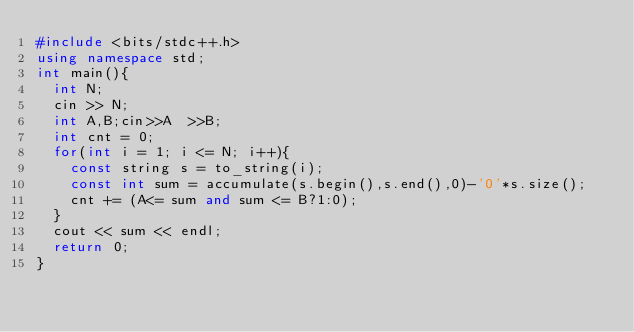<code> <loc_0><loc_0><loc_500><loc_500><_C++_>#include <bits/stdc++.h>
using namespace std;
int main(){
  int N;
  cin >> N;
  int A,B;cin>>A  >>B;
  int cnt = 0;
  for(int i = 1; i <= N; i++){
  	const string s = to_string(i);
    const int sum = accumulate(s.begin(),s.end(),0)-'0'*s.size();
  	cnt += (A<= sum and sum <= B?1:0);
  }
  cout << sum << endl;
  return 0;
}</code> 